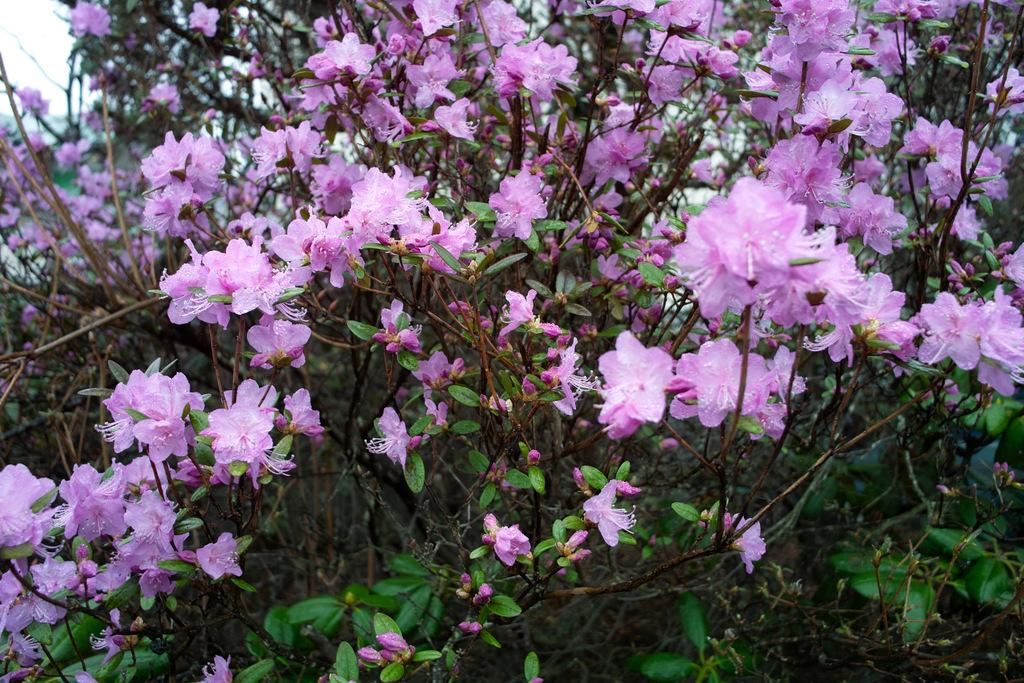What type of living organisms can be seen in the image? Plants can be seen in the image. What stage of growth are the plants in? The plants have buds and flowers. What color are the flowers? The flowers are pink in color. What can be seen in the background of the image? There is a sky visible in the background of the image. What type of question is being asked in the image? There is no question being asked in the image; it features plants with buds and flowers. Can you describe the cast of characters in the image? There are no characters in the image, as it only contains plants with buds and flowers. 